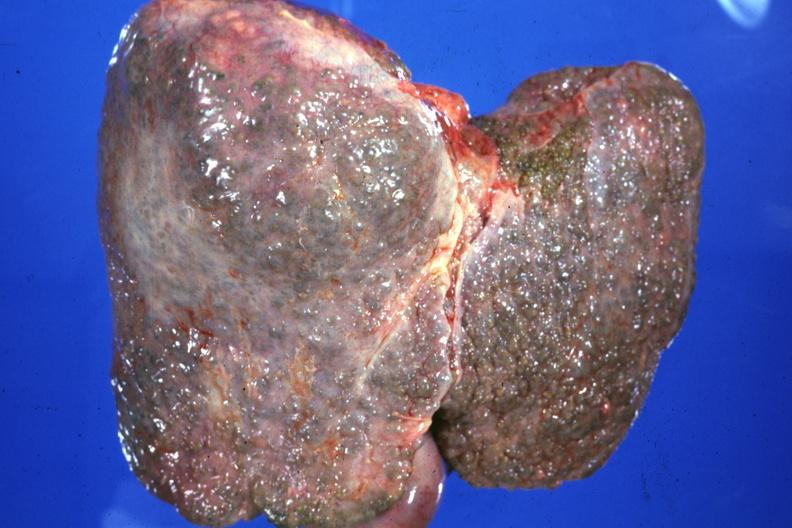s liver present?
Answer the question using a single word or phrase. Yes 